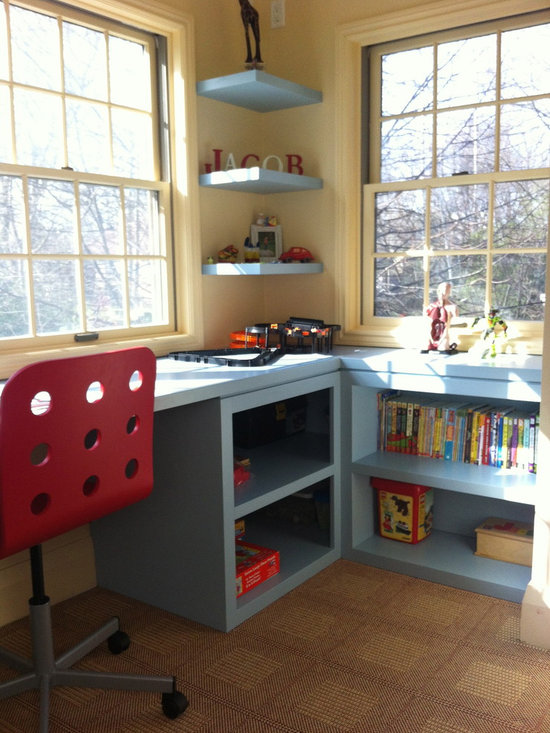What can we infer about the child’s interests from the items displayed? The items on display suggest that the child has a diverse range of interests. The presence of a train set implies an interest in mechanical objects or transport themes, while the assortment of books indicates a liking for reading and could point to a broad range of subjects such as animals, adventures, or fairy tales. The use of standout, cheerful colors throughout the space, and a decorative giraffe sculpture, also hints at a playful and imaginative personality. Collectively, these insights reflect a child engaged in both intellectual and creative activities.  Are there any elements here that might help in the development of organizational skills? Yes, the design of the space seems thoughtfully planned to nurture organizational skills. The shelving units allow for the categorization and neat arrangement of books and toys, fostering a habit of tidying up after play. The desk provides ample workspace for arts, crafts, or homework, potentially encouraging the child to organize their activities and supplies efficiently. Moreover, the general neatness and order of the room can play a crucial role in teaching the child the value of maintaining a clean and organized environment. 